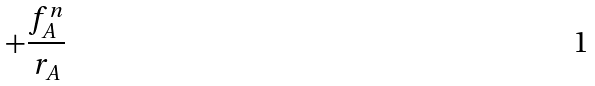<formula> <loc_0><loc_0><loc_500><loc_500>+ \frac { f _ { A } ^ { n } } { r _ { A } }</formula> 